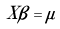Convert formula to latex. <formula><loc_0><loc_0><loc_500><loc_500>X { \beta } = \mu \,</formula> 